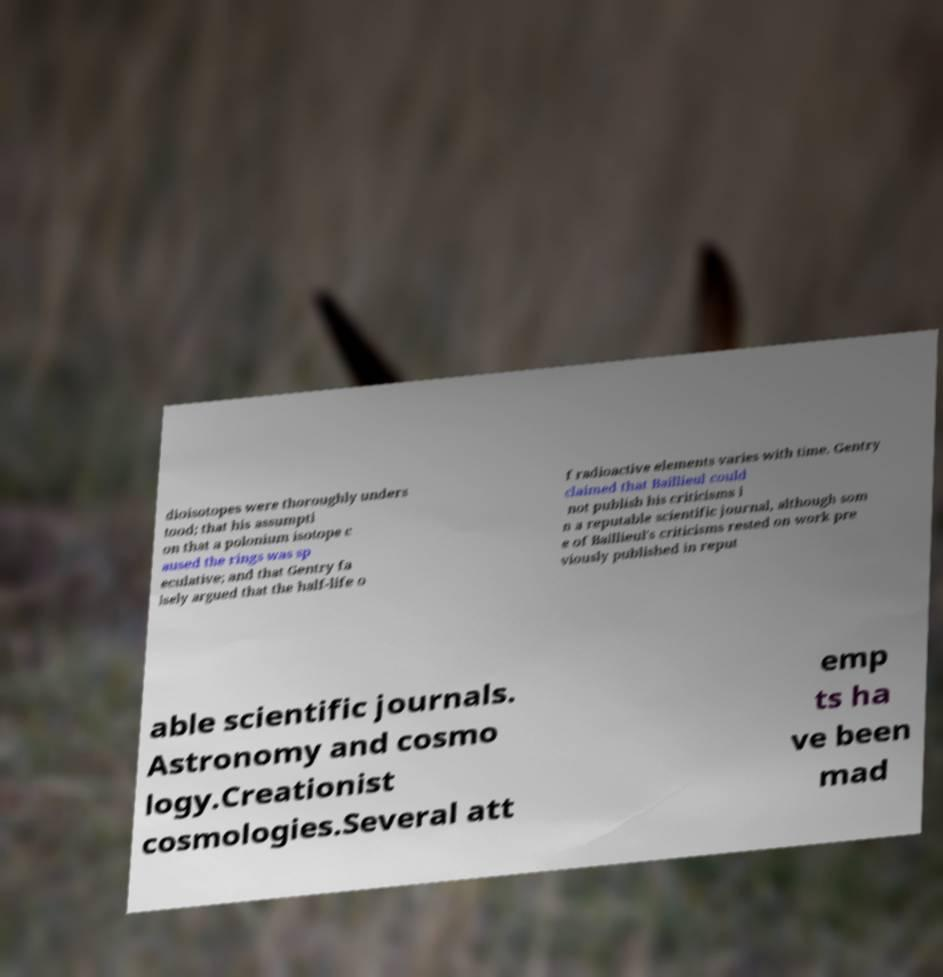Can you accurately transcribe the text from the provided image for me? dioisotopes were thoroughly unders tood; that his assumpti on that a polonium isotope c aused the rings was sp eculative; and that Gentry fa lsely argued that the half-life o f radioactive elements varies with time. Gentry claimed that Baillieul could not publish his criticisms i n a reputable scientific journal, although som e of Baillieul's criticisms rested on work pre viously published in reput able scientific journals. Astronomy and cosmo logy.Creationist cosmologies.Several att emp ts ha ve been mad 